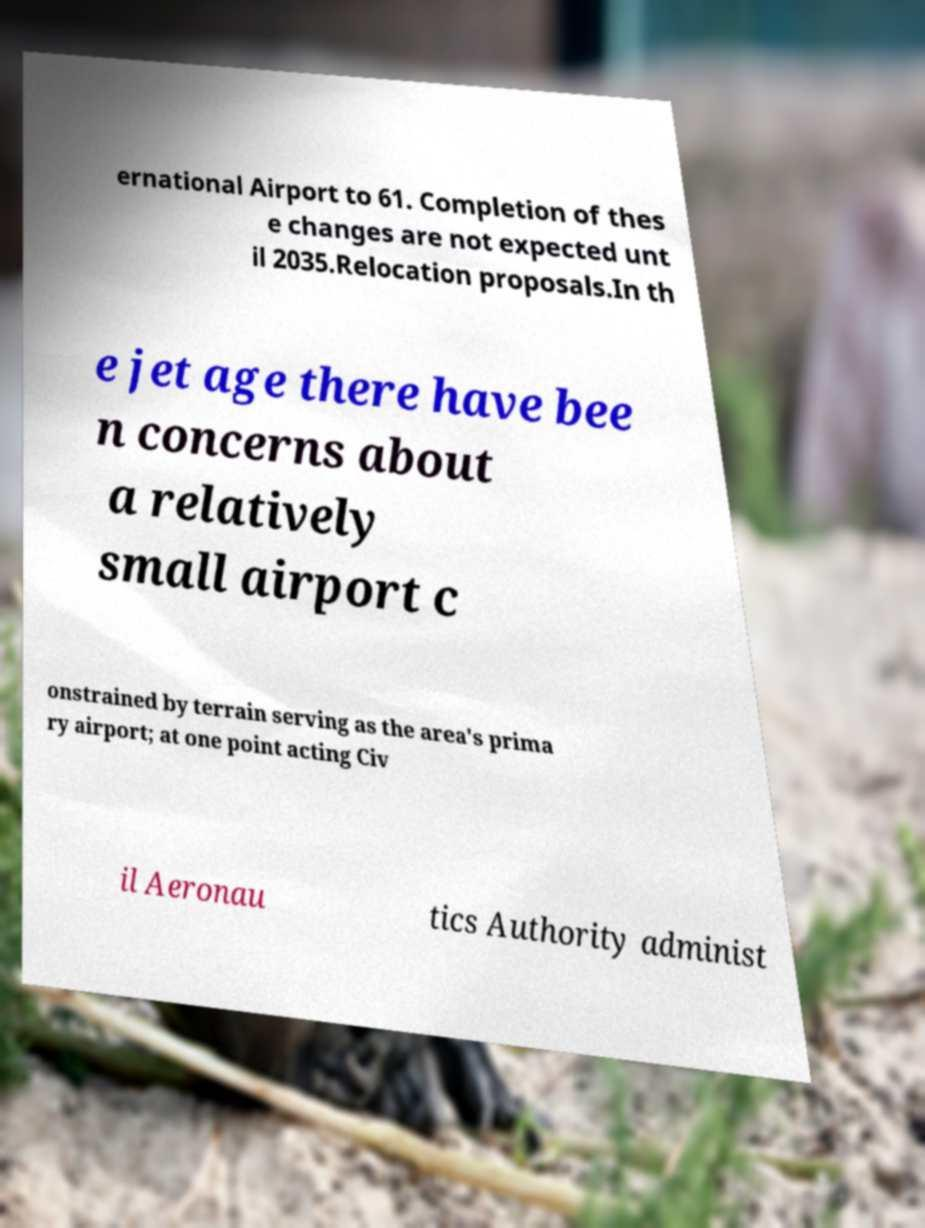Could you assist in decoding the text presented in this image and type it out clearly? ernational Airport to 61. Completion of thes e changes are not expected unt il 2035.Relocation proposals.In th e jet age there have bee n concerns about a relatively small airport c onstrained by terrain serving as the area's prima ry airport; at one point acting Civ il Aeronau tics Authority administ 